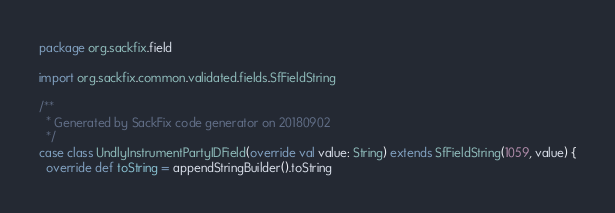Convert code to text. <code><loc_0><loc_0><loc_500><loc_500><_Scala_>package org.sackfix.field

import org.sackfix.common.validated.fields.SfFieldString

/**
  * Generated by SackFix code generator on 20180902
  */
case class UndlyInstrumentPartyIDField(override val value: String) extends SfFieldString(1059, value) {
  override def toString = appendStringBuilder().toString</code> 